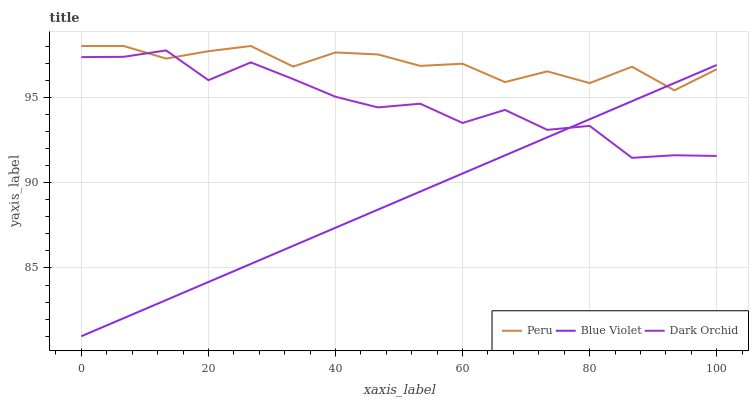Does Blue Violet have the minimum area under the curve?
Answer yes or no. Yes. Does Peru have the maximum area under the curve?
Answer yes or no. Yes. Does Peru have the minimum area under the curve?
Answer yes or no. No. Does Blue Violet have the maximum area under the curve?
Answer yes or no. No. Is Blue Violet the smoothest?
Answer yes or no. Yes. Is Dark Orchid the roughest?
Answer yes or no. Yes. Is Peru the smoothest?
Answer yes or no. No. Is Peru the roughest?
Answer yes or no. No. Does Blue Violet have the lowest value?
Answer yes or no. Yes. Does Peru have the lowest value?
Answer yes or no. No. Does Peru have the highest value?
Answer yes or no. Yes. Does Blue Violet have the highest value?
Answer yes or no. No. Does Blue Violet intersect Peru?
Answer yes or no. Yes. Is Blue Violet less than Peru?
Answer yes or no. No. Is Blue Violet greater than Peru?
Answer yes or no. No. 